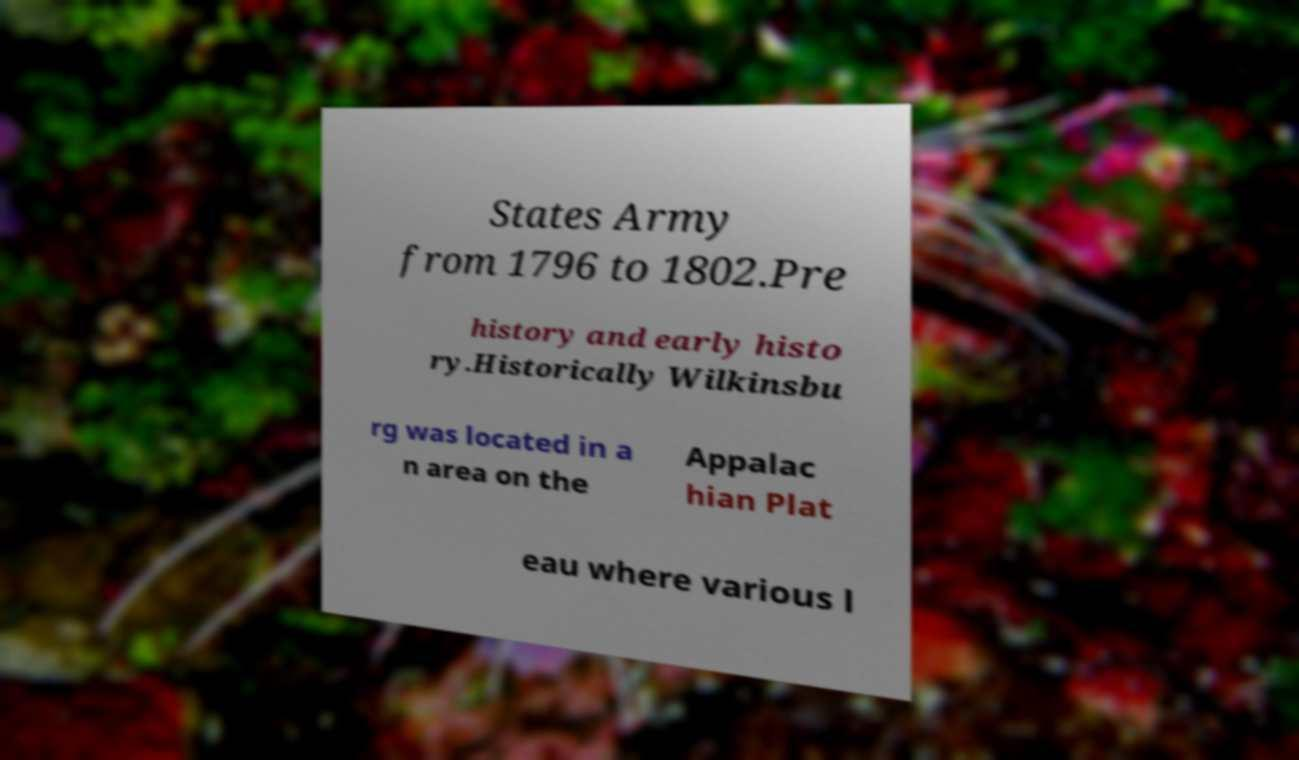I need the written content from this picture converted into text. Can you do that? States Army from 1796 to 1802.Pre history and early histo ry.Historically Wilkinsbu rg was located in a n area on the Appalac hian Plat eau where various l 